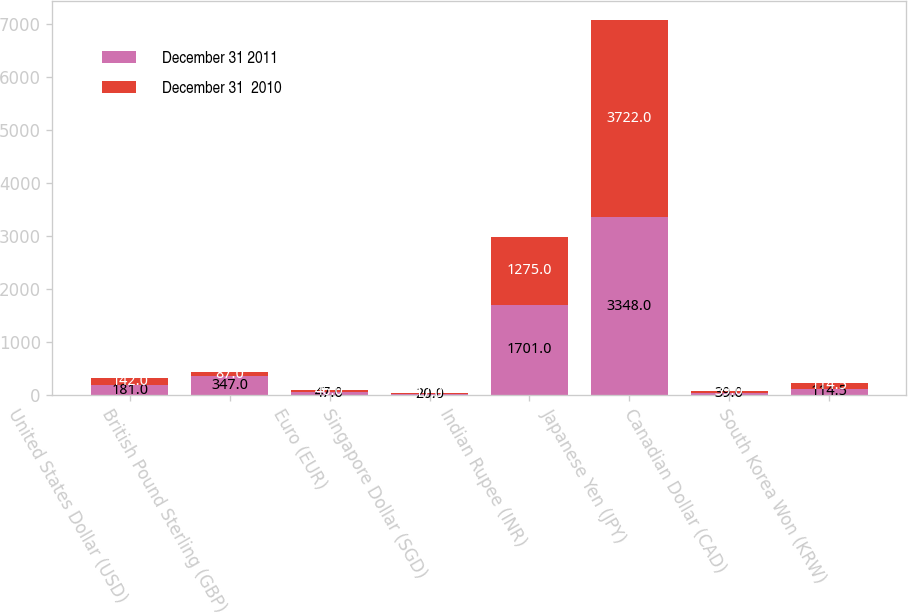Convert chart. <chart><loc_0><loc_0><loc_500><loc_500><stacked_bar_chart><ecel><fcel>United States Dollar (USD)<fcel>British Pound Sterling (GBP)<fcel>Euro (EUR)<fcel>Singapore Dollar (SGD)<fcel>Indian Rupee (INR)<fcel>Japanese Yen (JPY)<fcel>Canadian Dollar (CAD)<fcel>South Korea Won (KRW)<nl><fcel>December 31 2011<fcel>181<fcel>347<fcel>47<fcel>20<fcel>1701<fcel>3348<fcel>39<fcel>114.5<nl><fcel>December 31  2010<fcel>142<fcel>87<fcel>46<fcel>17<fcel>1275<fcel>3722<fcel>39<fcel>114.5<nl></chart> 